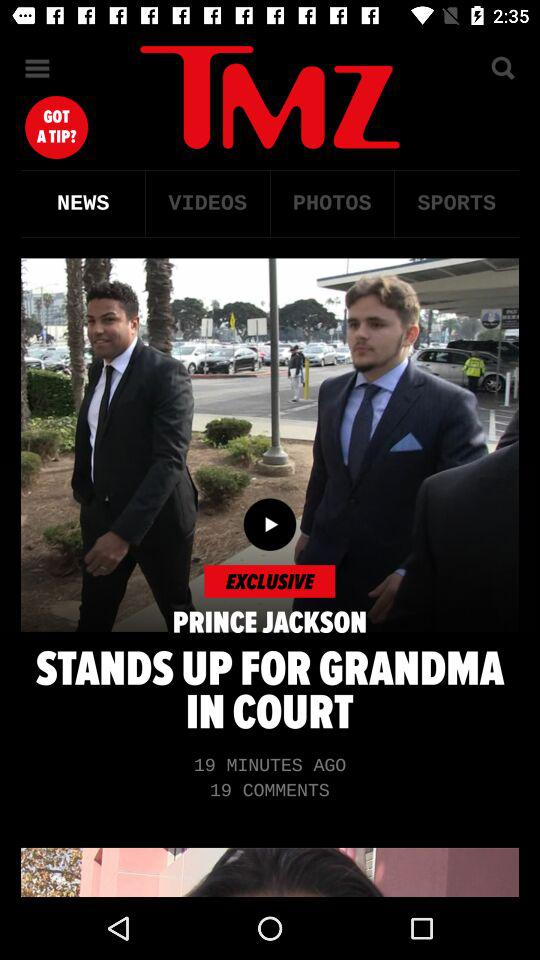Who wrote "PRINCE JACKSON STANDS UP FOR GRANDMA IN COURT"?
When the provided information is insufficient, respond with <no answer>. <no answer> 